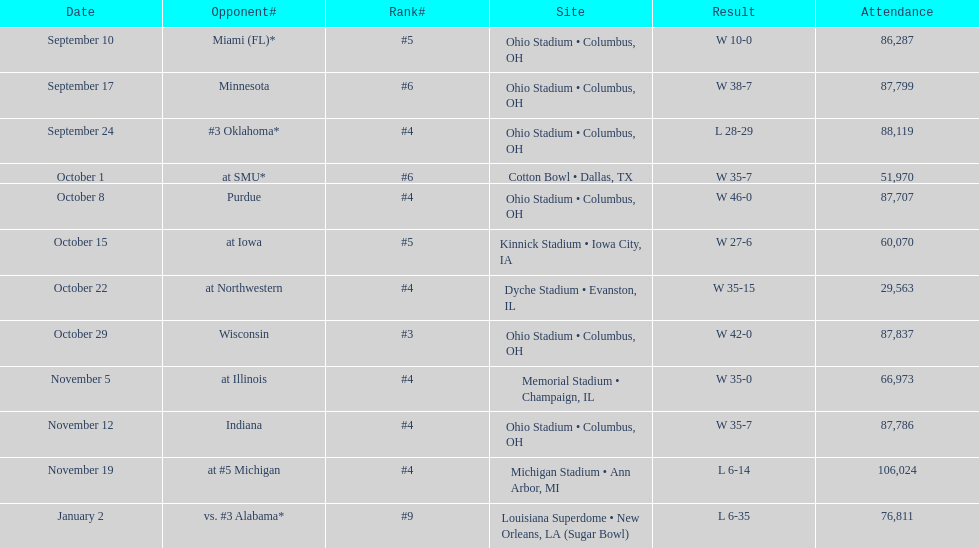When was the date with the maximum attendance? November 19. 